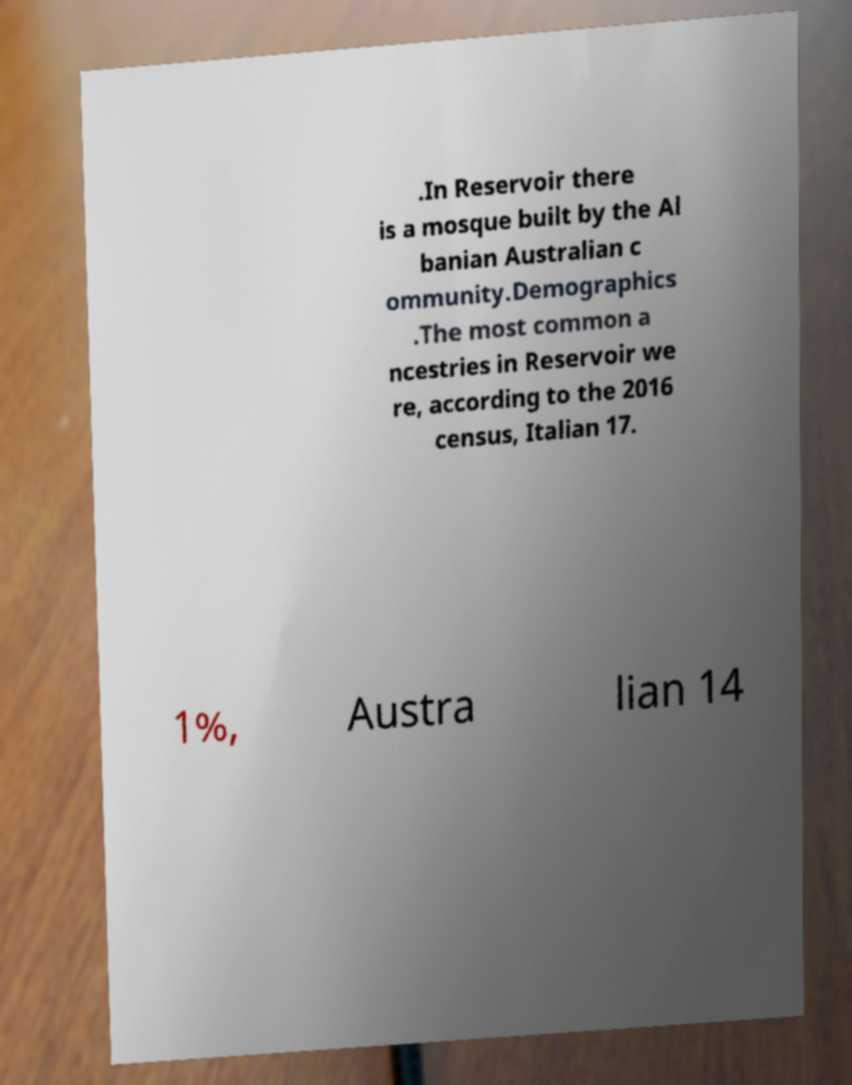For documentation purposes, I need the text within this image transcribed. Could you provide that? .In Reservoir there is a mosque built by the Al banian Australian c ommunity.Demographics .The most common a ncestries in Reservoir we re, according to the 2016 census, Italian 17. 1%, Austra lian 14 